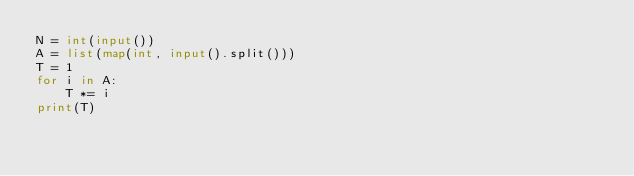<code> <loc_0><loc_0><loc_500><loc_500><_Python_>N = int(input())
A = list(map(int, input().split()))
T = 1
for i in A:
    T *= i
print(T)</code> 